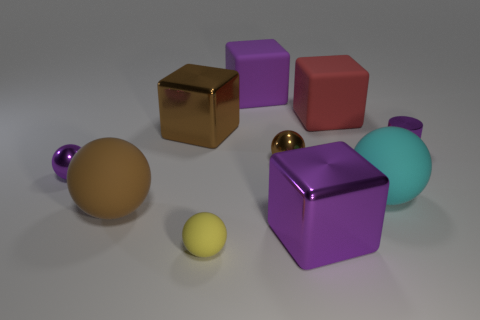The tiny metallic thing that is the same color as the small shiny cylinder is what shape?
Give a very brief answer. Sphere. What material is the large sphere that is right of the large block that is on the right side of the cube in front of the tiny purple ball?
Your answer should be very brief. Rubber. Is there anything else that has the same color as the shiny cylinder?
Your answer should be compact. Yes. What number of things are either large cubes or brown blocks left of the tiny brown metal object?
Make the answer very short. 4. Is the material of the large cyan object the same as the large brown ball?
Offer a very short reply. Yes. What number of other things are there of the same shape as the red object?
Your answer should be very brief. 3. What is the size of the purple metallic thing that is behind the big brown sphere and to the right of the small matte thing?
Your answer should be compact. Small. How many shiny things are either large yellow things or big objects?
Offer a very short reply. 2. Is the shape of the purple object behind the cylinder the same as the large rubber object that is left of the big brown cube?
Offer a very short reply. No. Are there any tiny things made of the same material as the brown cube?
Provide a succinct answer. Yes. 